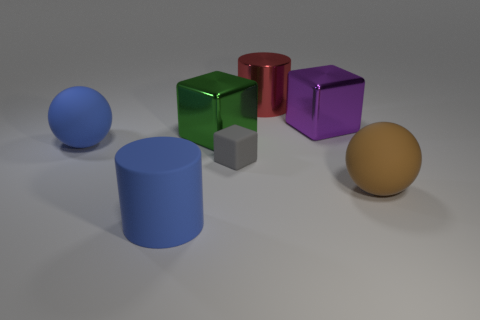Subtract all metal cubes. How many cubes are left? 1 Subtract 1 blocks. How many blocks are left? 2 Subtract all big cylinders. Subtract all cubes. How many objects are left? 2 Add 1 small objects. How many small objects are left? 2 Add 4 large blue blocks. How many large blue blocks exist? 4 Add 3 rubber things. How many objects exist? 10 Subtract all purple cubes. How many cubes are left? 2 Subtract 0 yellow cylinders. How many objects are left? 7 Subtract all cylinders. How many objects are left? 5 Subtract all red cubes. Subtract all brown cylinders. How many cubes are left? 3 